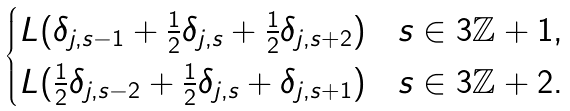Convert formula to latex. <formula><loc_0><loc_0><loc_500><loc_500>\begin{cases} L ( \delta _ { j , s - 1 } + \frac { 1 } { 2 } \delta _ { j , s } + \frac { 1 } { 2 } \delta _ { j , s + 2 } ) & s \in 3 { \mathbb { Z } } + 1 , \\ L ( \frac { 1 } { 2 } \delta _ { j , s - 2 } + \frac { 1 } { 2 } \delta _ { j , s } + \delta _ { j , s + 1 } ) & s \in 3 { \mathbb { Z } } + 2 . \end{cases}</formula> 